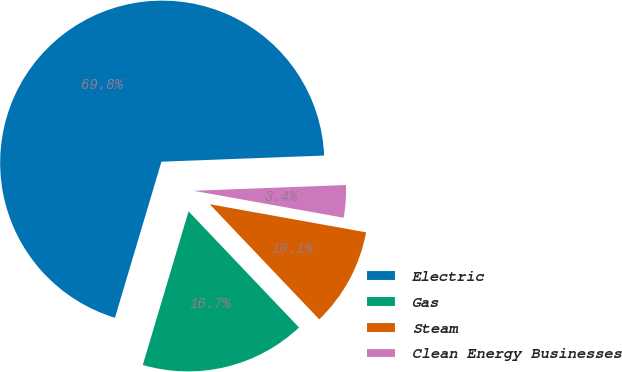<chart> <loc_0><loc_0><loc_500><loc_500><pie_chart><fcel>Electric<fcel>Gas<fcel>Steam<fcel>Clean Energy Businesses<nl><fcel>69.79%<fcel>16.71%<fcel>10.07%<fcel>3.43%<nl></chart> 